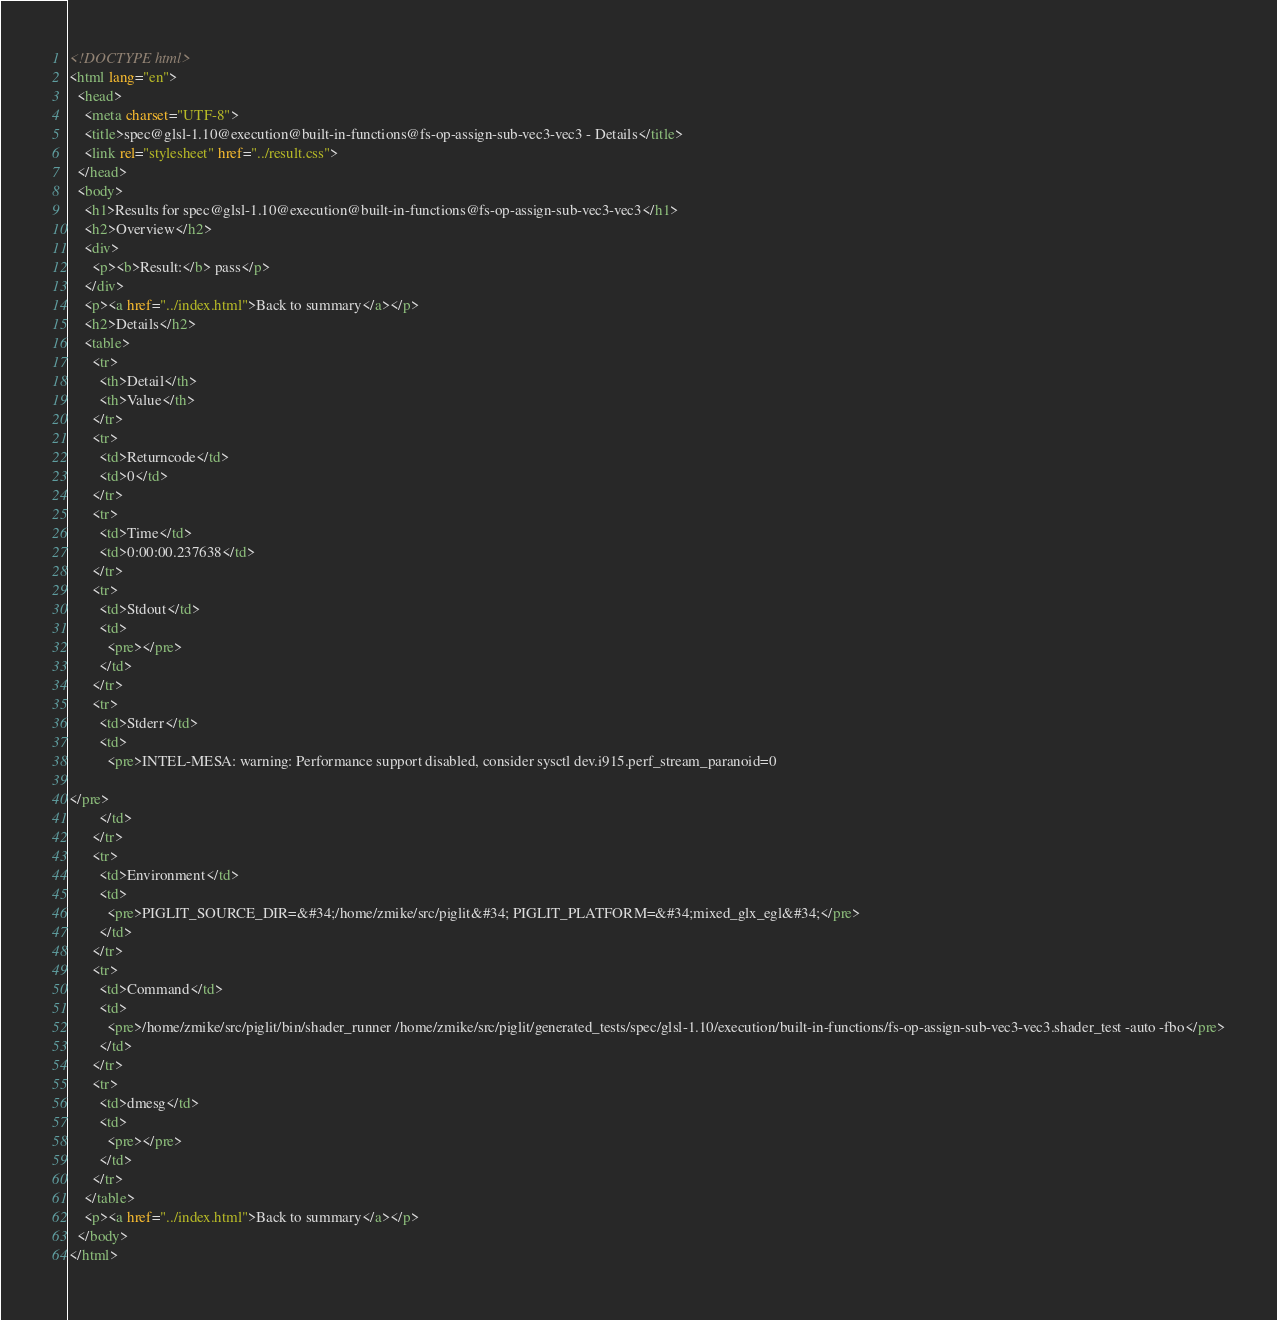<code> <loc_0><loc_0><loc_500><loc_500><_HTML_><!DOCTYPE html>
<html lang="en">
  <head>
    <meta charset="UTF-8">
    <title>spec@glsl-1.10@execution@built-in-functions@fs-op-assign-sub-vec3-vec3 - Details</title>
    <link rel="stylesheet" href="../result.css">
  </head>
  <body>
    <h1>Results for spec@glsl-1.10@execution@built-in-functions@fs-op-assign-sub-vec3-vec3</h1>
    <h2>Overview</h2>
    <div>
      <p><b>Result:</b> pass</p>
    </div>
    <p><a href="../index.html">Back to summary</a></p>
    <h2>Details</h2>
    <table>
      <tr>
        <th>Detail</th>
        <th>Value</th>
      </tr>
      <tr>
        <td>Returncode</td>
        <td>0</td>
      </tr>
      <tr>
        <td>Time</td>
        <td>0:00:00.237638</td>
      </tr>
      <tr>
        <td>Stdout</td>
        <td>
          <pre></pre>
        </td>
      </tr>
      <tr>
        <td>Stderr</td>
        <td>
          <pre>INTEL-MESA: warning: Performance support disabled, consider sysctl dev.i915.perf_stream_paranoid=0

</pre>
        </td>
      </tr>
      <tr>
        <td>Environment</td>
        <td>
          <pre>PIGLIT_SOURCE_DIR=&#34;/home/zmike/src/piglit&#34; PIGLIT_PLATFORM=&#34;mixed_glx_egl&#34;</pre>
        </td>
      </tr>
      <tr>
        <td>Command</td>
        <td>
          <pre>/home/zmike/src/piglit/bin/shader_runner /home/zmike/src/piglit/generated_tests/spec/glsl-1.10/execution/built-in-functions/fs-op-assign-sub-vec3-vec3.shader_test -auto -fbo</pre>
        </td>
      </tr>
      <tr>
        <td>dmesg</td>
        <td>
          <pre></pre>
        </td>
      </tr>
    </table>
    <p><a href="../index.html">Back to summary</a></p>
  </body>
</html>
</code> 